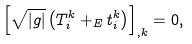Convert formula to latex. <formula><loc_0><loc_0><loc_500><loc_500>\left [ \sqrt { | g | } \left ( T _ { i } ^ { k } + _ { E } t _ { i } ^ { k } \right ) \right ] _ { , k } = 0 ,</formula> 